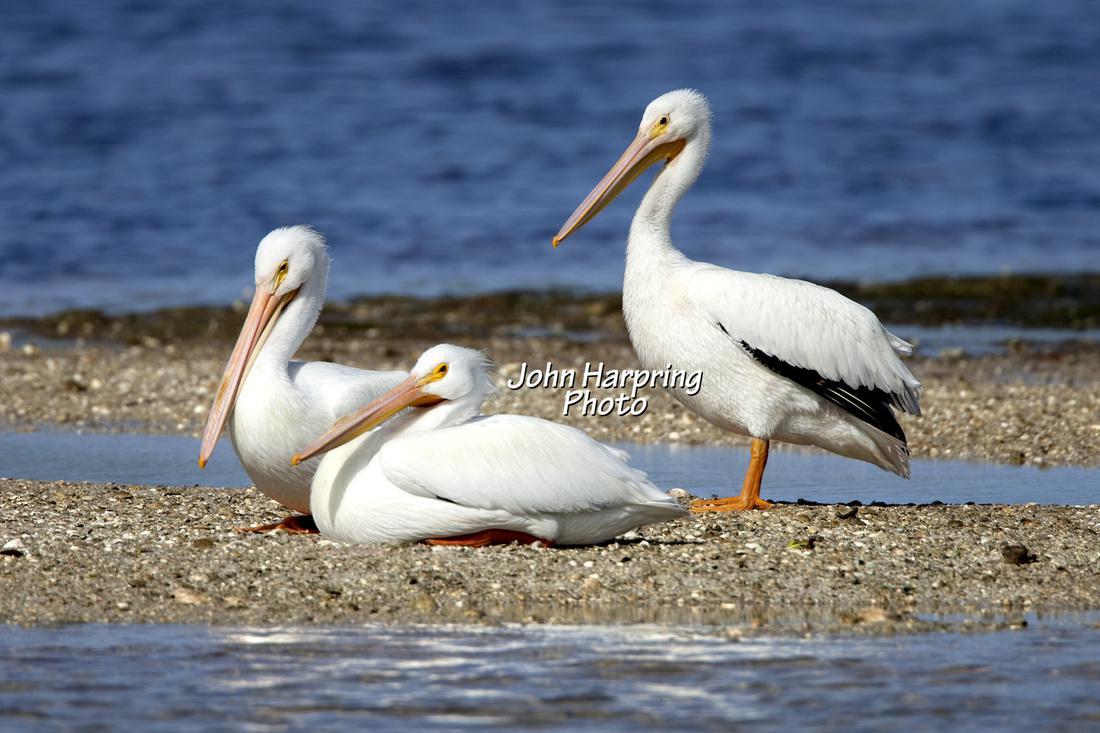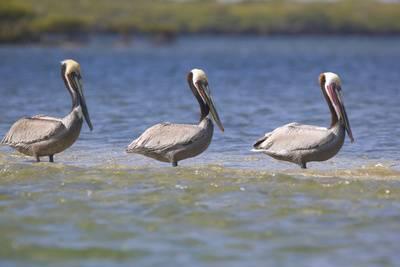The first image is the image on the left, the second image is the image on the right. Assess this claim about the two images: "An image contains a trio of similarly posed left-facing pelicans with white heads and grey bodies.". Correct or not? Answer yes or no. No. The first image is the image on the left, the second image is the image on the right. Evaluate the accuracy of this statement regarding the images: "The right image contains exactly three birds all looking towards the left.". Is it true? Answer yes or no. No. 